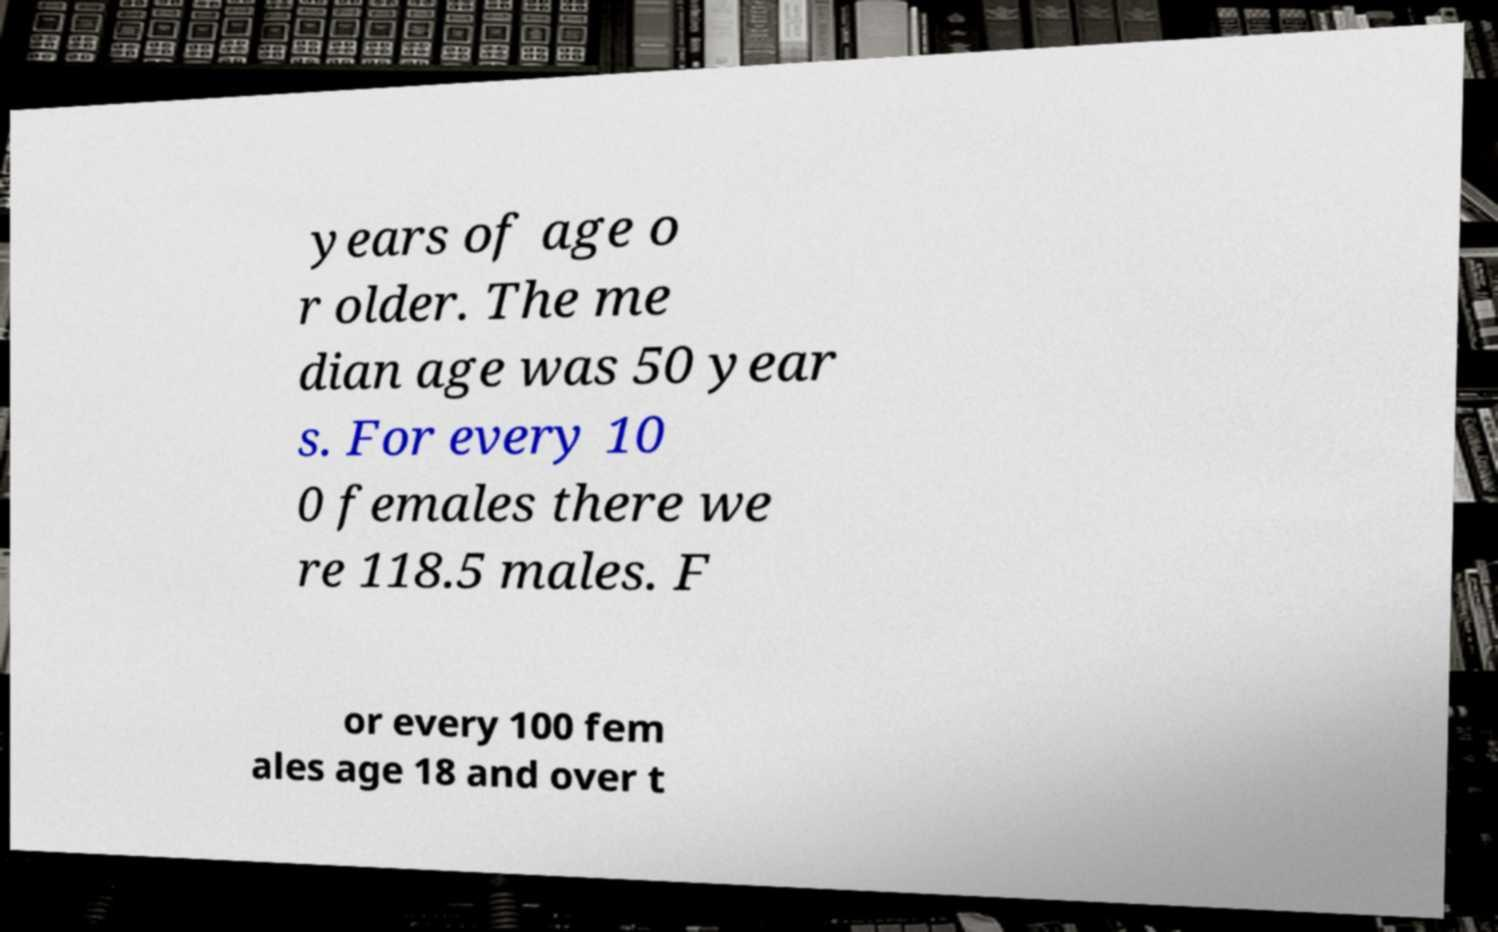Please identify and transcribe the text found in this image. years of age o r older. The me dian age was 50 year s. For every 10 0 females there we re 118.5 males. F or every 100 fem ales age 18 and over t 